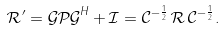Convert formula to latex. <formula><loc_0><loc_0><loc_500><loc_500>\mathcal { R ^ { \prime } } = \mathcal { G P G } ^ { H } + \mathcal { I } = \mathcal { C } ^ { - \frac { 1 } { 2 } } \, \mathcal { R } \, \mathcal { C } ^ { - \frac { 1 } { 2 } } .</formula> 